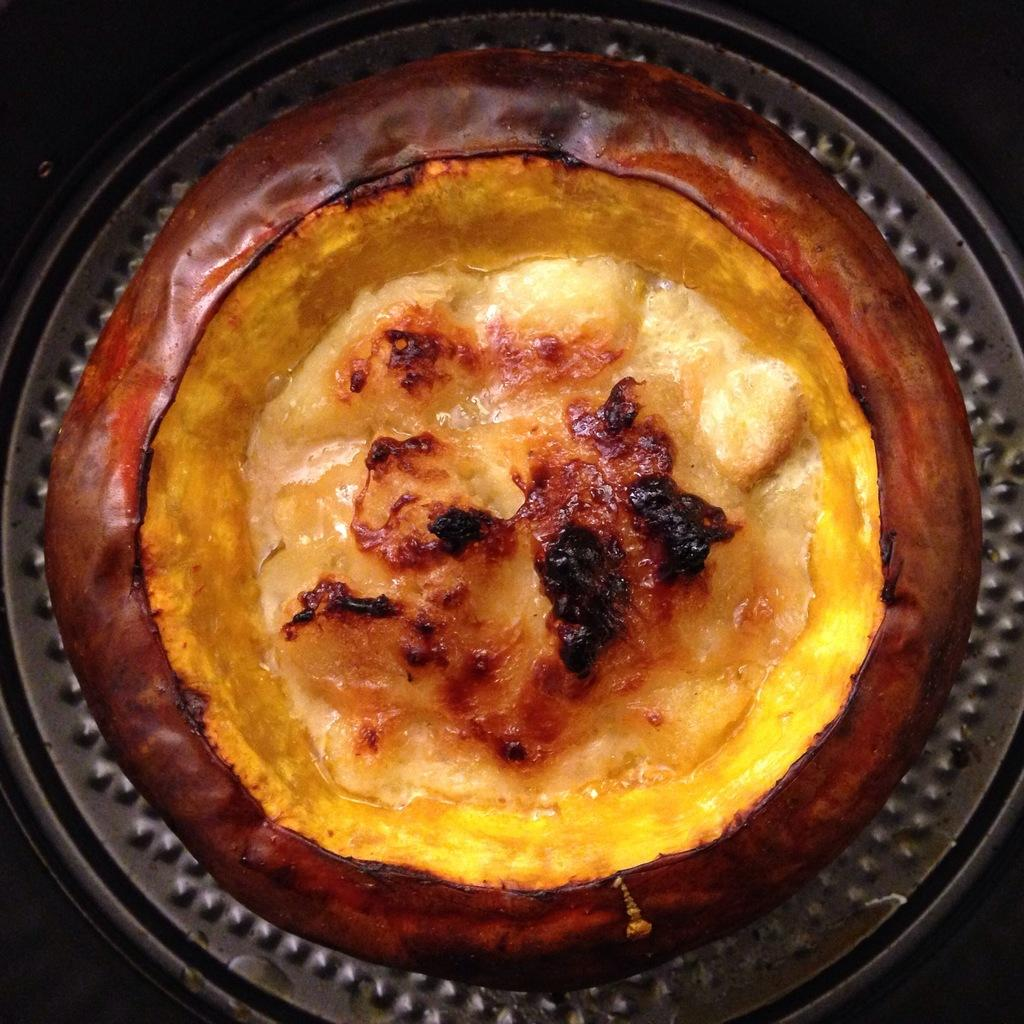What is present in the image? There is a bowl in the image. What is inside the bowl? There is a food item in the bowl. How many pigs are visible in the image? There are no pigs present in the image. What type of bean is being used to create the earthquake in the image? There is no bean or earthquake present in the image. 